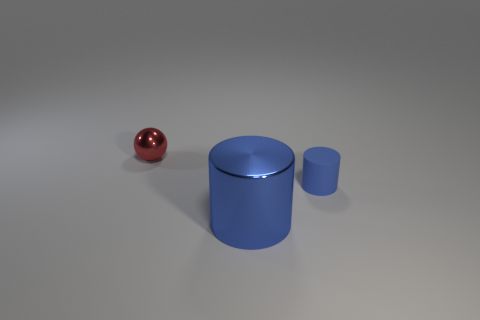There is a shiny thing left of the blue metal cylinder; is its shape the same as the blue rubber object?
Provide a succinct answer. No. Is the number of large blue cylinders that are in front of the blue metal thing greater than the number of big matte cylinders?
Your answer should be compact. No. Are there any other things that have the same material as the red sphere?
Your answer should be compact. Yes. There is a shiny object that is the same color as the small cylinder; what shape is it?
Keep it short and to the point. Cylinder. How many cubes are either tiny red metallic things or blue objects?
Provide a short and direct response. 0. What color is the shiny thing that is right of the tiny thing behind the small blue rubber cylinder?
Keep it short and to the point. Blue. There is a big metal cylinder; is its color the same as the small object that is right of the red metal sphere?
Your answer should be very brief. Yes. What size is the other object that is made of the same material as the red object?
Make the answer very short. Large. What size is the other matte cylinder that is the same color as the large cylinder?
Keep it short and to the point. Small. Does the small matte cylinder have the same color as the large object?
Provide a succinct answer. Yes. 